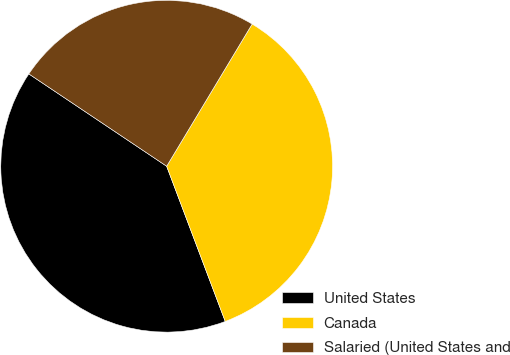Convert chart to OTSL. <chart><loc_0><loc_0><loc_500><loc_500><pie_chart><fcel>United States<fcel>Canada<fcel>Salaried (United States and<nl><fcel>40.14%<fcel>35.64%<fcel>24.22%<nl></chart> 